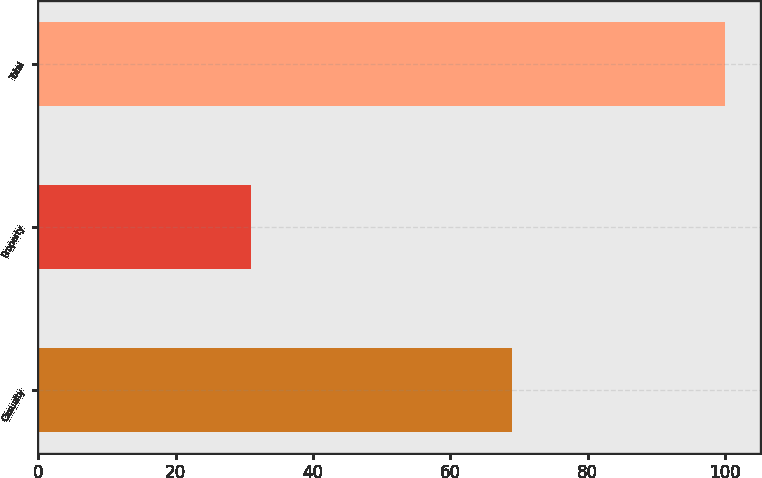<chart> <loc_0><loc_0><loc_500><loc_500><bar_chart><fcel>Casualty<fcel>Property<fcel>Total<nl><fcel>69<fcel>31<fcel>100<nl></chart> 